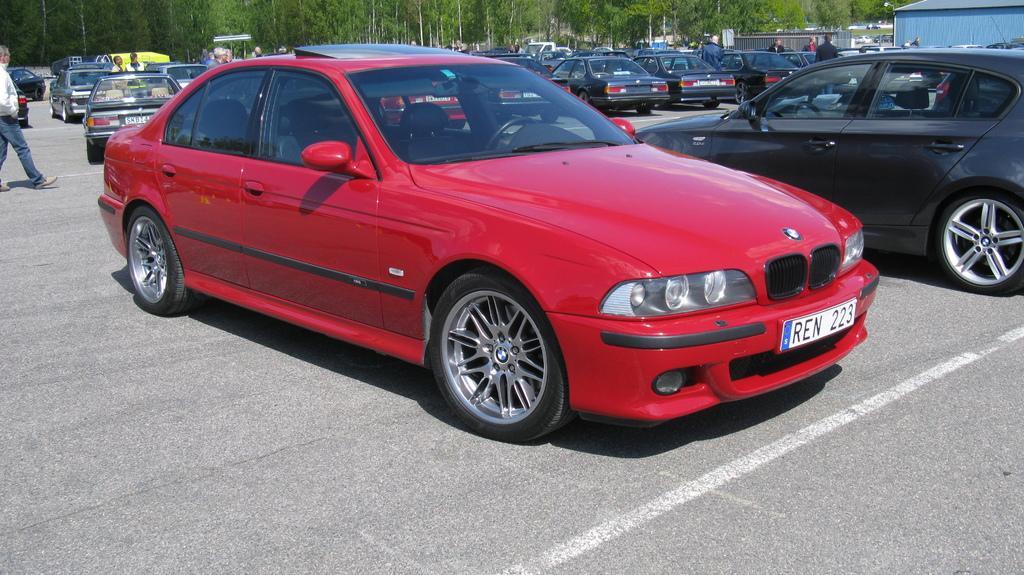Please provide a concise description of this image. In the image there are many cars on the road. And also there are few people. In the background there are trees. And also there is a shed. 